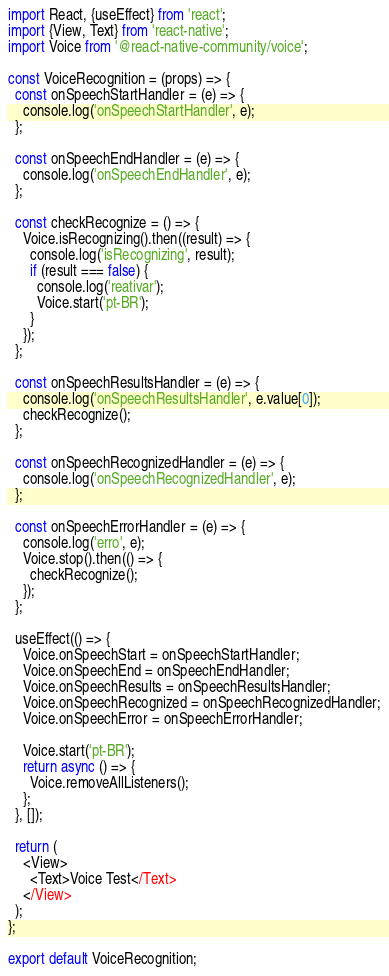<code> <loc_0><loc_0><loc_500><loc_500><_JavaScript_>import React, {useEffect} from 'react';
import {View, Text} from 'react-native';
import Voice from '@react-native-community/voice';

const VoiceRecognition = (props) => {
  const onSpeechStartHandler = (e) => {
    console.log('onSpeechStartHandler', e);
  };

  const onSpeechEndHandler = (e) => {
    console.log('onSpeechEndHandler', e);
  };

  const checkRecognize = () => {
    Voice.isRecognizing().then((result) => {
      console.log('isRecognizing', result);
      if (result === false) {
        console.log('reativar');
        Voice.start('pt-BR');
      }
    });
  };

  const onSpeechResultsHandler = (e) => {
    console.log('onSpeechResultsHandler', e.value[0]);
    checkRecognize();
  };

  const onSpeechRecognizedHandler = (e) => {
    console.log('onSpeechRecognizedHandler', e);
  };

  const onSpeechErrorHandler = (e) => {
    console.log('erro', e);
    Voice.stop().then(() => {
      checkRecognize();
    });
  };

  useEffect(() => {
    Voice.onSpeechStart = onSpeechStartHandler;
    Voice.onSpeechEnd = onSpeechEndHandler;
    Voice.onSpeechResults = onSpeechResultsHandler;
    Voice.onSpeechRecognized = onSpeechRecognizedHandler;
    Voice.onSpeechError = onSpeechErrorHandler;

    Voice.start('pt-BR');
    return async () => {
      Voice.removeAllListeners();
    };
  }, []);

  return (
    <View>
      <Text>Voice Test</Text>
    </View>
  );
};

export default VoiceRecognition;
</code> 